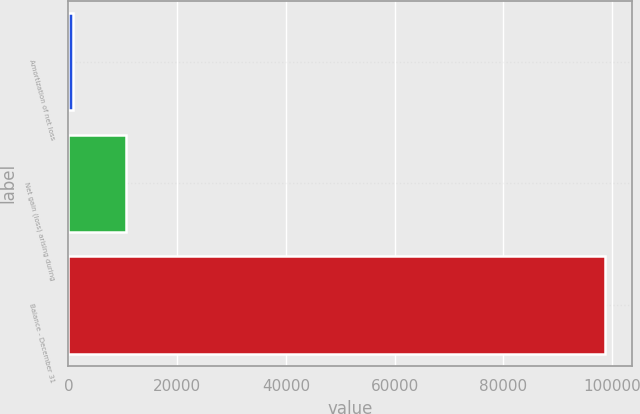<chart> <loc_0><loc_0><loc_500><loc_500><bar_chart><fcel>Amortization of net loss<fcel>Net gain (loss) arising during<fcel>Balance - December 31<nl><fcel>771<fcel>10568.4<fcel>98745<nl></chart> 